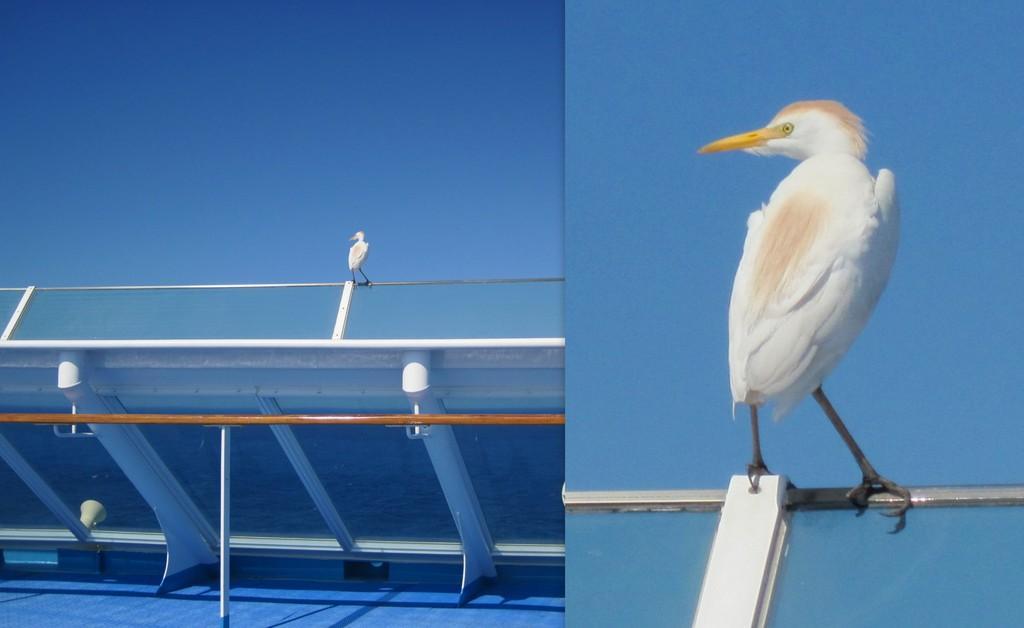Please provide a concise description of this image. In this image I can see the collage picture and I can see the bird on the railing and the bird is in white and cream color. In the background the sky is in blue color. 